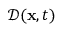<formula> <loc_0><loc_0><loc_500><loc_500>\mathcal { D } ( x , t )</formula> 